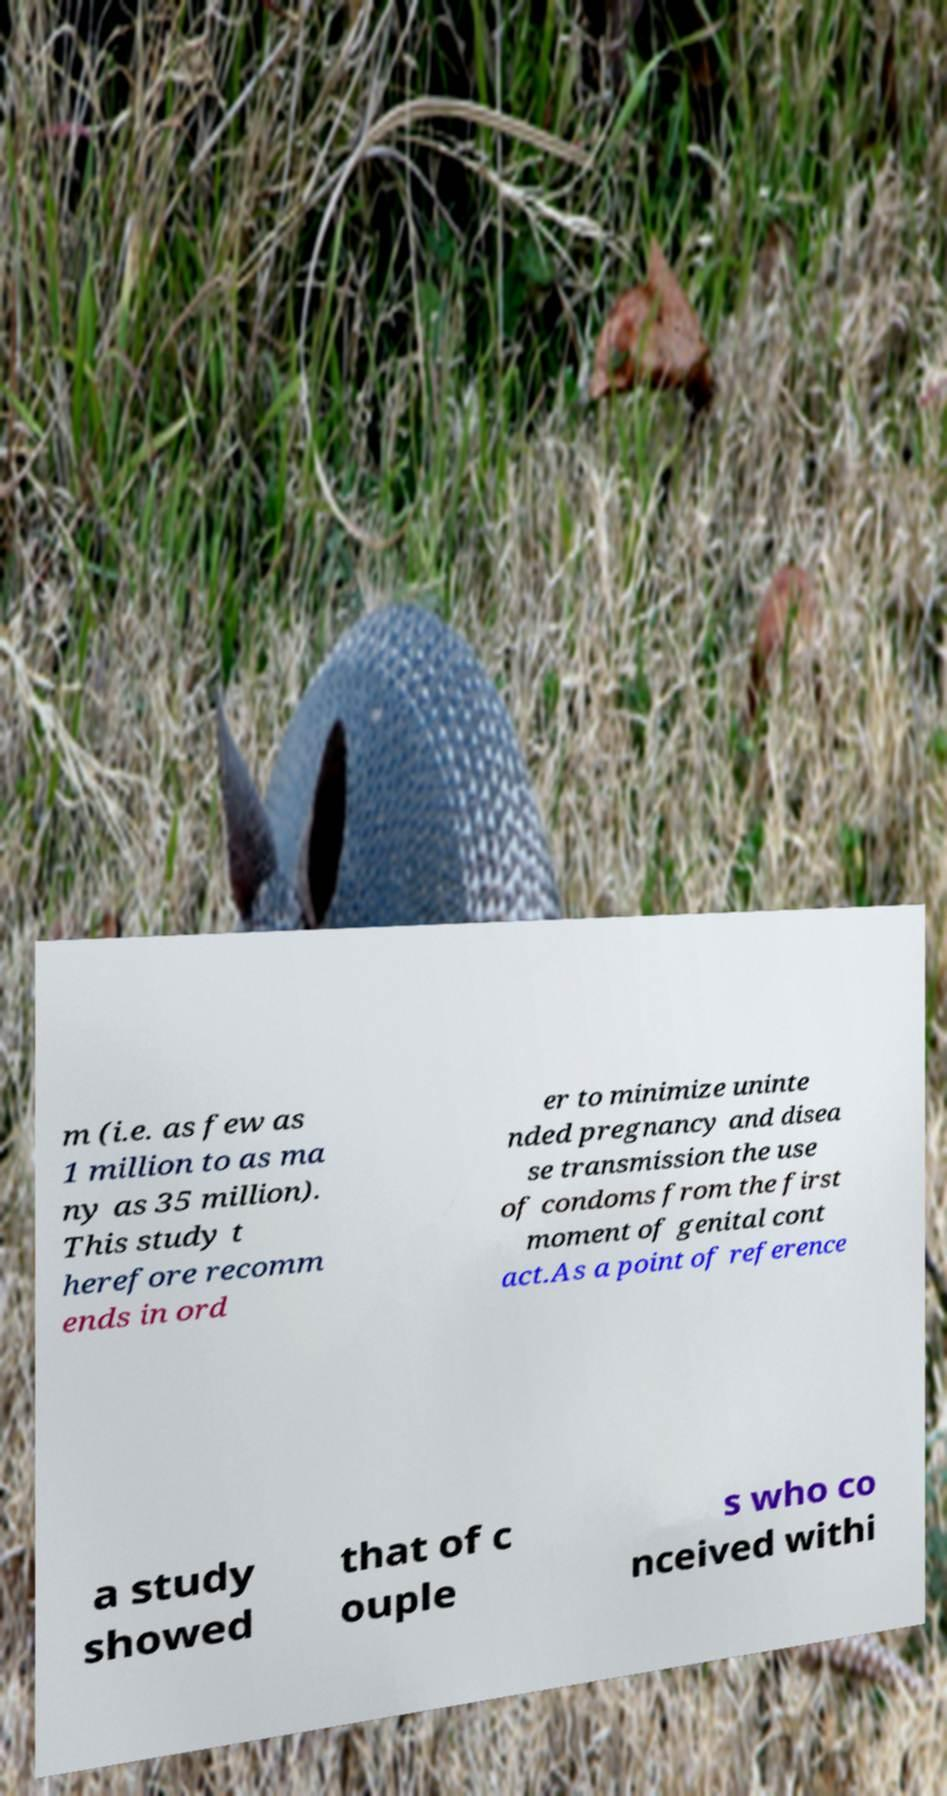For documentation purposes, I need the text within this image transcribed. Could you provide that? m (i.e. as few as 1 million to as ma ny as 35 million). This study t herefore recomm ends in ord er to minimize uninte nded pregnancy and disea se transmission the use of condoms from the first moment of genital cont act.As a point of reference a study showed that of c ouple s who co nceived withi 